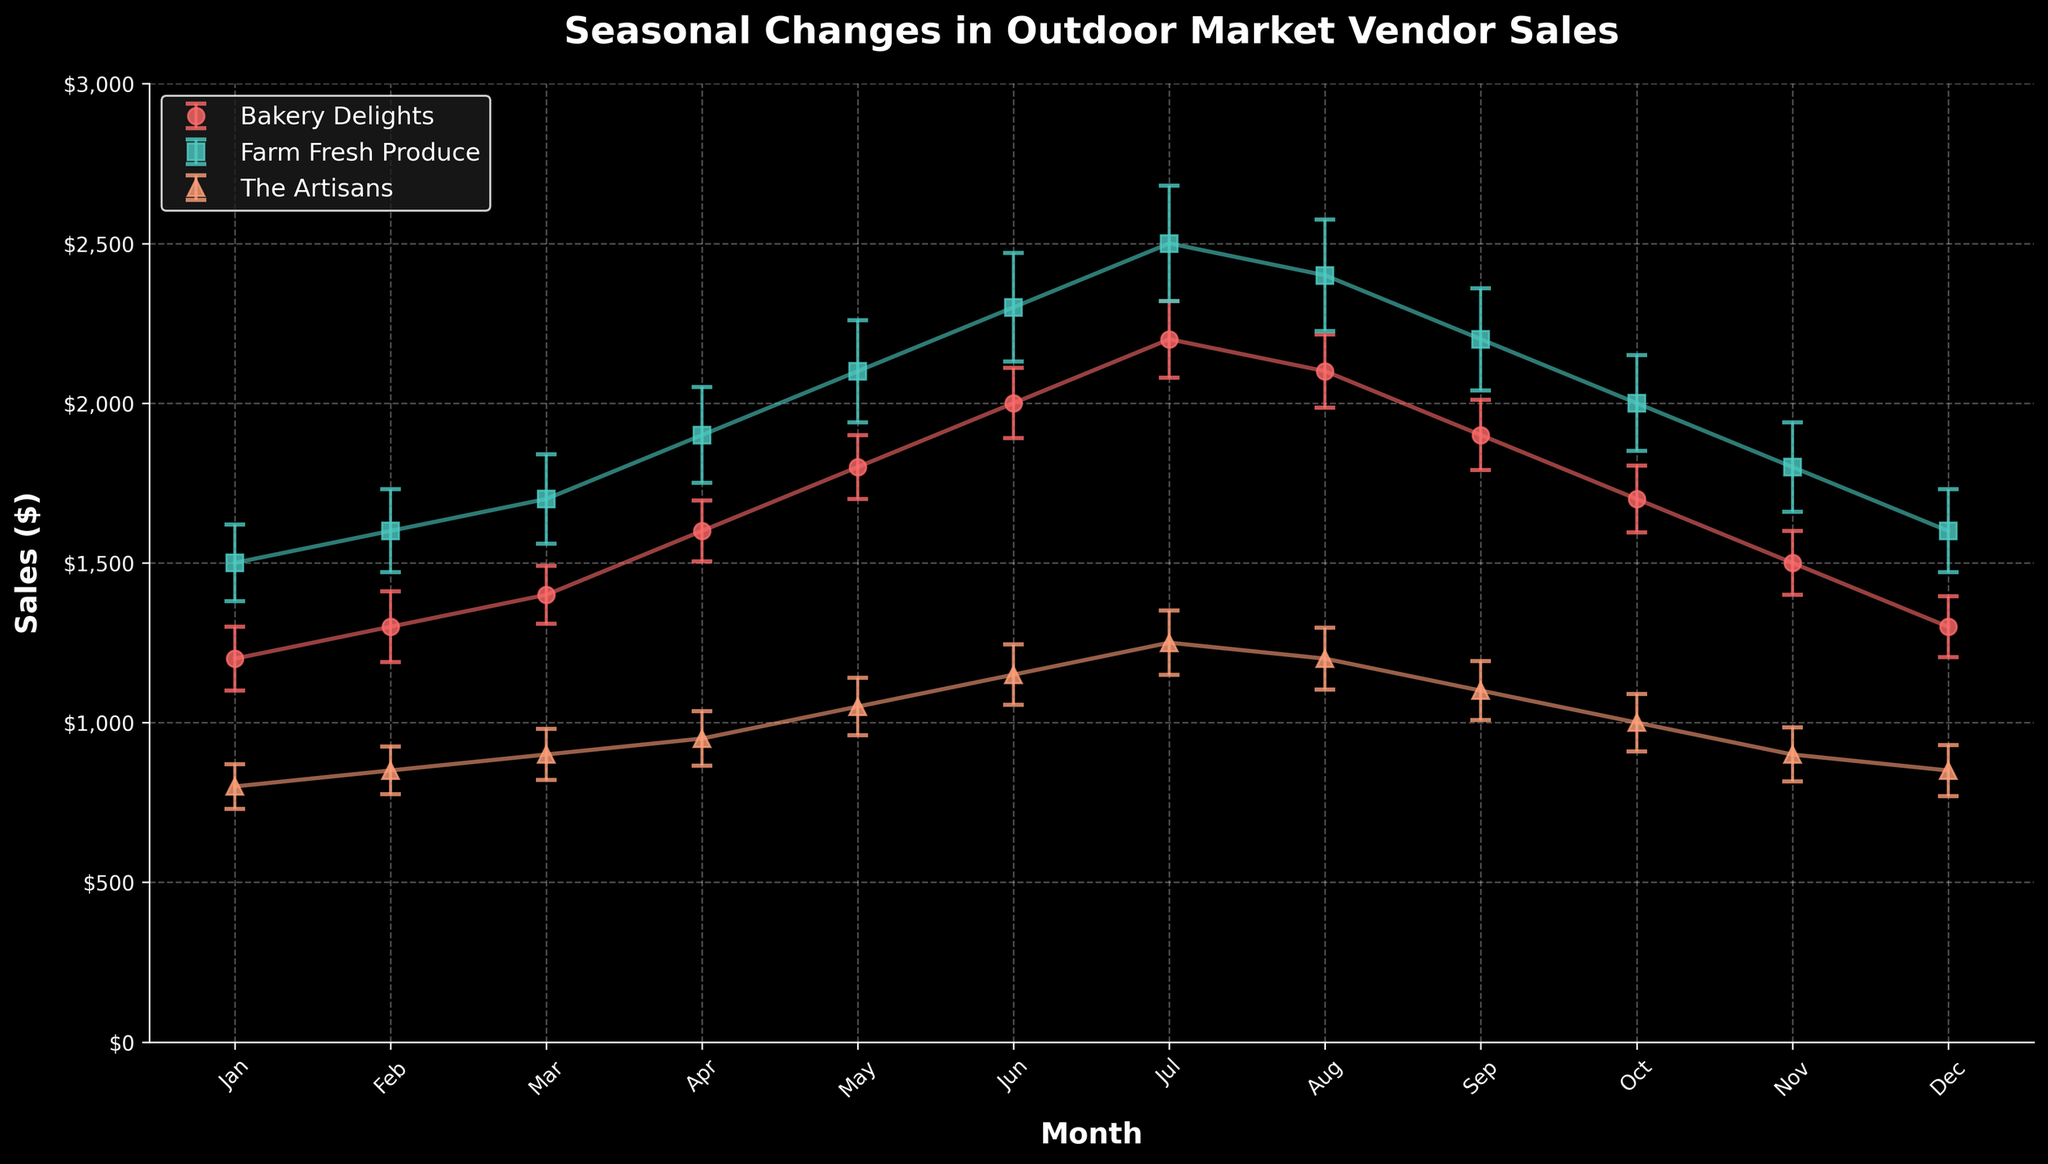What is the title of the figure? The title is displayed at the top of the figure.
Answer: Seasonal Changes in Outdoor Market Vendor Sales Which months show sales data on the x-axis? The x-axis is labeled with months abbreviation Jan to Dec.
Answer: January to December Which vendor had the highest sales in July? Look for the data point in July that is highest across all vendors.
Answer: Farm Fresh Produce What is the sales value for Bakery Delights in April, including the error margin? Locate the data point for Bakery Delights in April and add/subtract the error margin. The sales value is 1600 with an error of 95, so the range is 1505 to 1695.
Answer: 1600 ± 95 Which vendor had the lowest sales in November, and what was the value? Compare the sales data points for all vendors in November and identify the lowest one.
Answer: The Artisans had the lowest sales at 900 Between which two consecutive months did The Artisans experience their maximum increase in sales? Look for the month-to-month sales data for The Artisans and calculate the differences, identifying the maximum positive difference. The increase from April (950) to May (1050) is 100, the highest monthly increase.
Answer: April to May On average, which vendor had the lowest monthly sales, and what was the average value? Calculate the average sales for each vendor over the 12 months, then identify the lowest. The Artisans' sales sum is 11500 with an average of 11500/12 ≈ 958.33.
Answer: The Artisans, 958.33 Are there any months where Farm Fresh Produce's sales decreased compared to the previous month? If so, list the months. Examine the sales data for Farm Fresh Produce month-by-month to identify decreases. Sales decrease from July (2500) to August (2400) and from August (2400) to September (2200).
Answer: August, September Which vendor shows the most consistent sales over the year based on the error margins? Assess the error margins for all vendors across the year and identify the vendor with the smallest fluctuations. The Artisan's error margins range from 70 to 100, the most consistent among vendors.
Answer: The Artisans What is the total sales for Bakery Delights from January to June, and how does it compare to July to December? Sum the sales for January to June and compare it against the sum for July to December for Bakery Delights. January to June: 1200 + 1300 + 1400 + 1600 + 1800 + 2000 = 9300. July to December: 2200 + 2100 + 1900 + 1700 + 1500 + 1300 = 10700. The sum for July to December is 1400 higher.
Answer: 9300 vs 10700, July to December has higher sales 